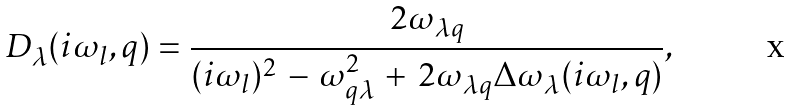<formula> <loc_0><loc_0><loc_500><loc_500>D _ { \lambda } ( i \omega _ { l } , { q } ) = \frac { 2 \omega _ { \lambda { q } } } { ( i \omega _ { l } ) ^ { 2 } \, - \, \omega _ { { q } \lambda } ^ { 2 } \, + \, 2 \omega _ { \lambda { q } } \Delta \omega _ { \lambda } ( i \omega _ { l } , { q } ) } ,</formula> 